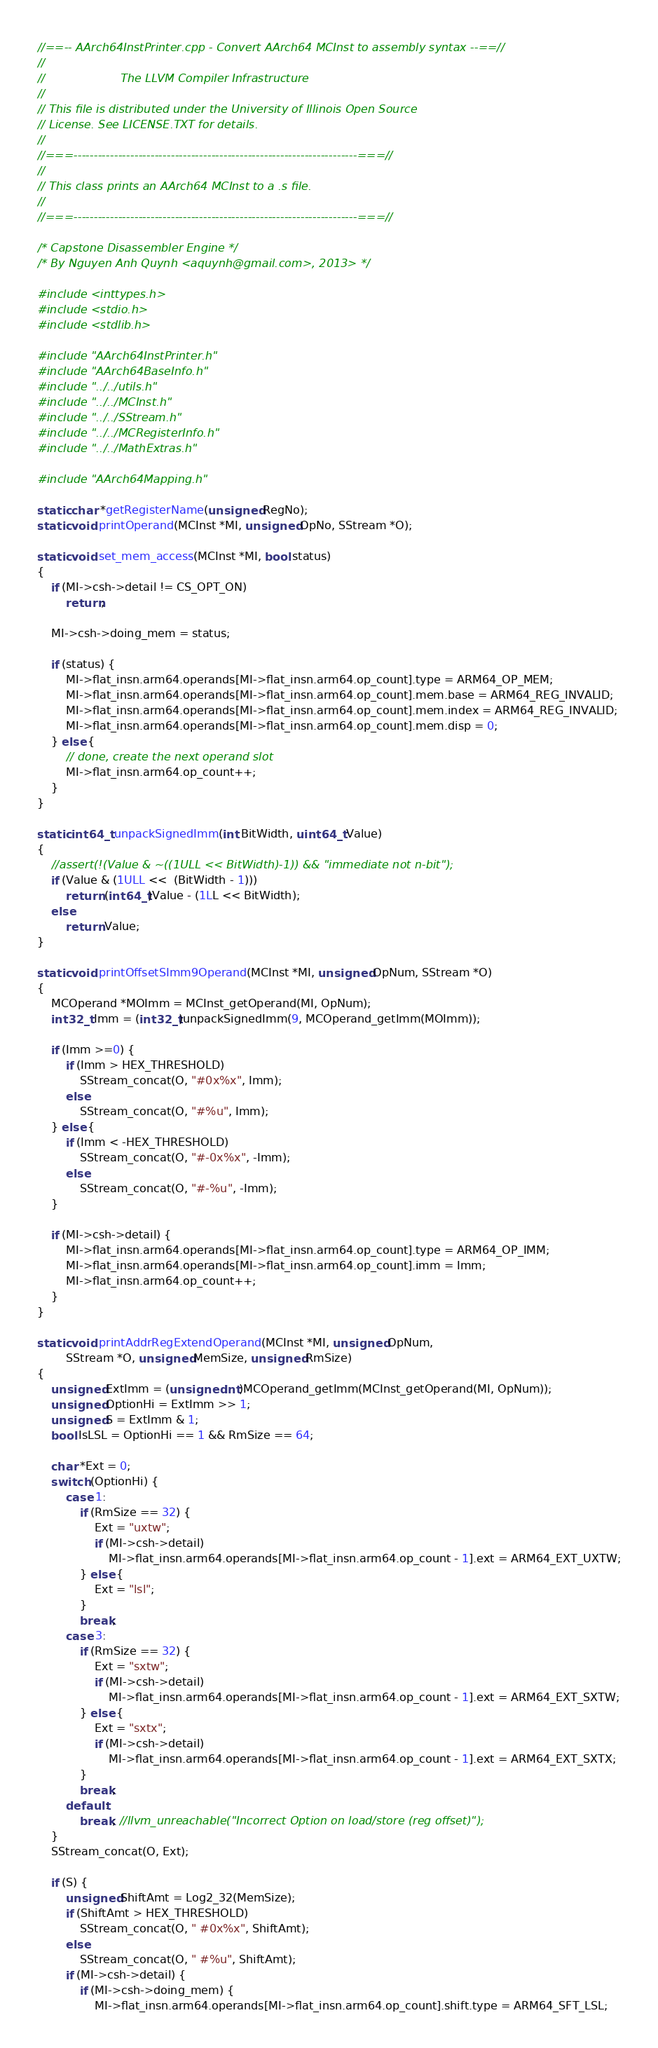<code> <loc_0><loc_0><loc_500><loc_500><_C_>//==-- AArch64InstPrinter.cpp - Convert AArch64 MCInst to assembly syntax --==//
//
//                     The LLVM Compiler Infrastructure
//
// This file is distributed under the University of Illinois Open Source
// License. See LICENSE.TXT for details.
//
//===----------------------------------------------------------------------===//
//
// This class prints an AArch64 MCInst to a .s file.
//
//===----------------------------------------------------------------------===//

/* Capstone Disassembler Engine */
/* By Nguyen Anh Quynh <aquynh@gmail.com>, 2013> */

#include <inttypes.h>
#include <stdio.h>
#include <stdlib.h>

#include "AArch64InstPrinter.h"
#include "AArch64BaseInfo.h"
#include "../../utils.h"
#include "../../MCInst.h"
#include "../../SStream.h"
#include "../../MCRegisterInfo.h"
#include "../../MathExtras.h"

#include "AArch64Mapping.h"

static char *getRegisterName(unsigned RegNo);
static void printOperand(MCInst *MI, unsigned OpNo, SStream *O);

static void set_mem_access(MCInst *MI, bool status)
{
	if (MI->csh->detail != CS_OPT_ON)
		return;

	MI->csh->doing_mem = status;

	if (status) {
		MI->flat_insn.arm64.operands[MI->flat_insn.arm64.op_count].type = ARM64_OP_MEM;
		MI->flat_insn.arm64.operands[MI->flat_insn.arm64.op_count].mem.base = ARM64_REG_INVALID;
		MI->flat_insn.arm64.operands[MI->flat_insn.arm64.op_count].mem.index = ARM64_REG_INVALID;
		MI->flat_insn.arm64.operands[MI->flat_insn.arm64.op_count].mem.disp = 0;
	} else {
		// done, create the next operand slot
		MI->flat_insn.arm64.op_count++;
	}
}

static int64_t unpackSignedImm(int BitWidth, uint64_t Value)
{
	//assert(!(Value & ~((1ULL << BitWidth)-1)) && "immediate not n-bit");
	if (Value & (1ULL <<  (BitWidth - 1)))
		return (int64_t)Value - (1LL << BitWidth);
	else
		return Value;
}

static void printOffsetSImm9Operand(MCInst *MI, unsigned OpNum, SStream *O)
{
	MCOperand *MOImm = MCInst_getOperand(MI, OpNum);
	int32_t Imm = (int32_t)unpackSignedImm(9, MCOperand_getImm(MOImm));

	if (Imm >=0) {
		if (Imm > HEX_THRESHOLD)
			SStream_concat(O, "#0x%x", Imm);
		else
			SStream_concat(O, "#%u", Imm);
	} else {
		if (Imm < -HEX_THRESHOLD)
			SStream_concat(O, "#-0x%x", -Imm);
		else
			SStream_concat(O, "#-%u", -Imm);
	}

	if (MI->csh->detail) {
		MI->flat_insn.arm64.operands[MI->flat_insn.arm64.op_count].type = ARM64_OP_IMM;
		MI->flat_insn.arm64.operands[MI->flat_insn.arm64.op_count].imm = Imm;
		MI->flat_insn.arm64.op_count++;
	}
}

static void printAddrRegExtendOperand(MCInst *MI, unsigned OpNum,
		SStream *O, unsigned MemSize, unsigned RmSize)
{
	unsigned ExtImm = (unsigned int)MCOperand_getImm(MCInst_getOperand(MI, OpNum));
	unsigned OptionHi = ExtImm >> 1;
	unsigned S = ExtImm & 1;
	bool IsLSL = OptionHi == 1 && RmSize == 64;

	char *Ext = 0;
	switch (OptionHi) {
		case 1:
			if (RmSize == 32) {
				Ext = "uxtw";
				if (MI->csh->detail)
					MI->flat_insn.arm64.operands[MI->flat_insn.arm64.op_count - 1].ext = ARM64_EXT_UXTW;
			} else {
				Ext = "lsl";
			}
			break;
		case 3:
			if (RmSize == 32) {
				Ext = "sxtw";
				if (MI->csh->detail)
					MI->flat_insn.arm64.operands[MI->flat_insn.arm64.op_count - 1].ext = ARM64_EXT_SXTW;
			} else {
				Ext = "sxtx";
				if (MI->csh->detail)
					MI->flat_insn.arm64.operands[MI->flat_insn.arm64.op_count - 1].ext = ARM64_EXT_SXTX;
			}
			break;
		default:
			break; //llvm_unreachable("Incorrect Option on load/store (reg offset)");
	}
	SStream_concat(O, Ext);

	if (S) {
		unsigned ShiftAmt = Log2_32(MemSize);
		if (ShiftAmt > HEX_THRESHOLD)
			SStream_concat(O, " #0x%x", ShiftAmt);
		else
			SStream_concat(O, " #%u", ShiftAmt);
		if (MI->csh->detail) {
			if (MI->csh->doing_mem) {
				MI->flat_insn.arm64.operands[MI->flat_insn.arm64.op_count].shift.type = ARM64_SFT_LSL;</code> 